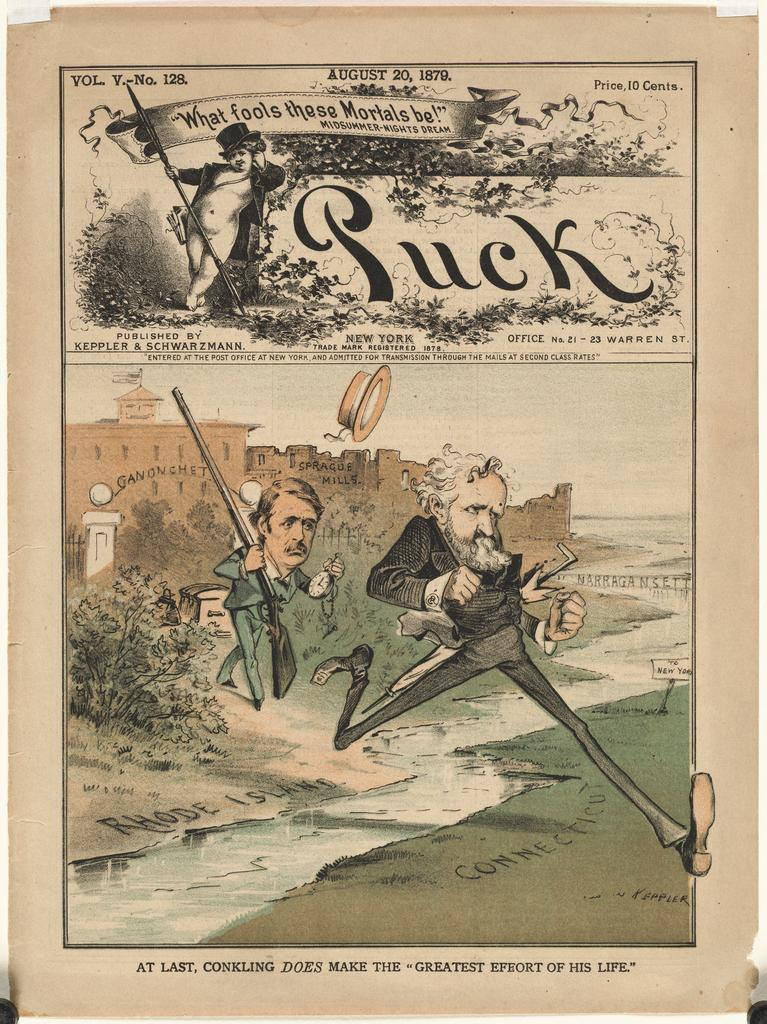<image>
Create a compact narrative representing the image presented. Two cartoon men characters with the quote that fools these mortals be. 